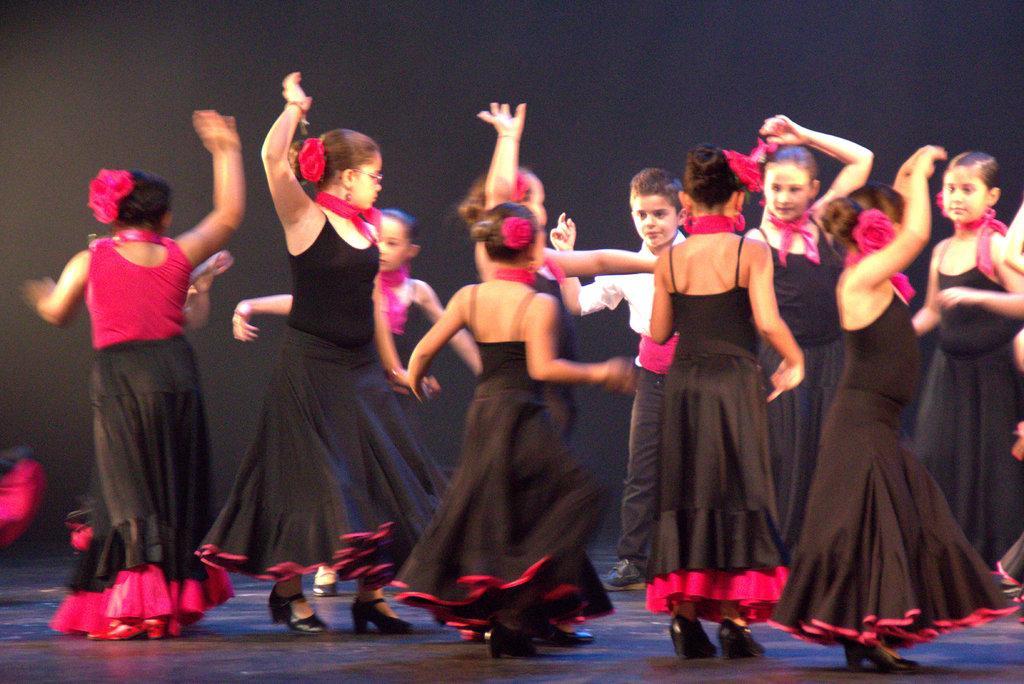In one or two sentences, can you explain what this image depicts? In this image I can see group of girls wearing a black color dress and performing a dance on the stage and between them I can see a boy and in background I can see dark view. 